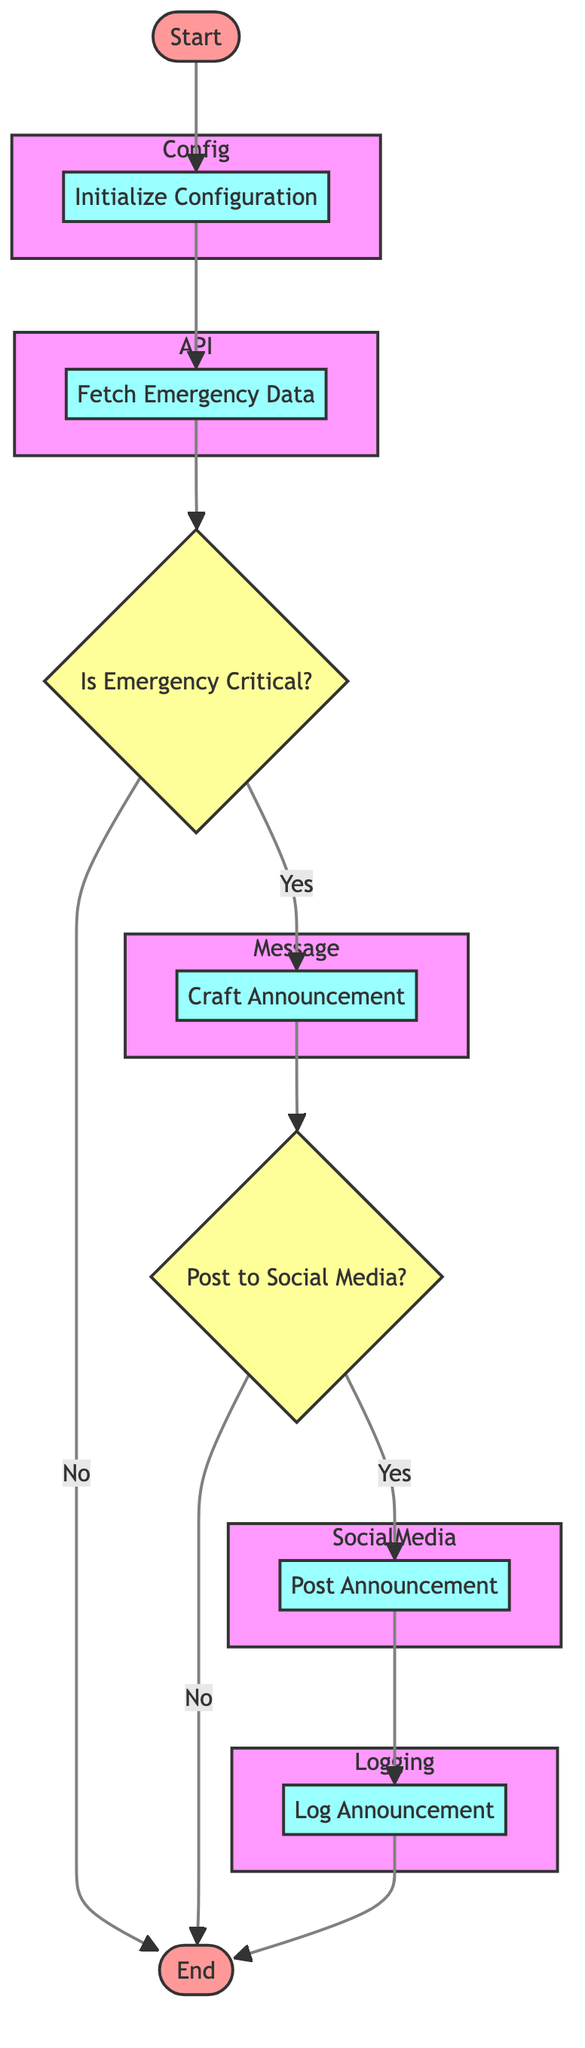What is the first step in the process? The first element in the flowchart is "Start," which indicates the beginning of the process. This is connected as the initial node in the flow.
Answer: Start How many decision nodes are there in the diagram? The diagram contains two decision nodes: "Is Emergency Critical?" and "Post to Social Media?" Therefore, by counting these nodes, we arrive at the answer.
Answer: 2 What does the "Fetch Emergency Data" node do? This process retrieves the latest emergency information from a specified Government API endpoint. It represents an essential step to gather data before making announcements.
Answer: Retrieve latest emergency information What happens if the emergency is not classified as critical? If the emergency is not classified as critical, the flowchart indicates that it will lead directly to the end of the process without further action taken. Therefore, no announcement will be crafted or posted.
Answer: End What are the platforms used for posting announcements? The platforms for posting announcements specified in the process are Twitter and Facebook, as depicted in the "Post Announcement" node detailing their respective API endpoints.
Answer: Twitter, Facebook What action occurs after crafting the announcement? After crafting the announcement, the next decision node checks whether the crafted announcement will be posted to social media, which is a pivotal point in determining the next step.
Answer: Post to Social Media? What is recorded in the log after posting an announcement? Once the announcement is posted, the next step involves logging the details of that posted announcement in a log file or database, ensuring that records are maintained of the actions taken.
Answer: Details of the posted announcement What is the URL for the emergency data API? The URL for the emergency data API is provided in the "Fetch Emergency Data" process, and this is essential for retrieving the latest emergency information needed for announcements.
Answer: https://govapi.gov/emergency/latest What happens if the crafted announcement is not posted? If the announcement is not posted, the flowchart indicates that the process will terminate at the end node directly after that decision, indicating no further action will be taken.
Answer: End 